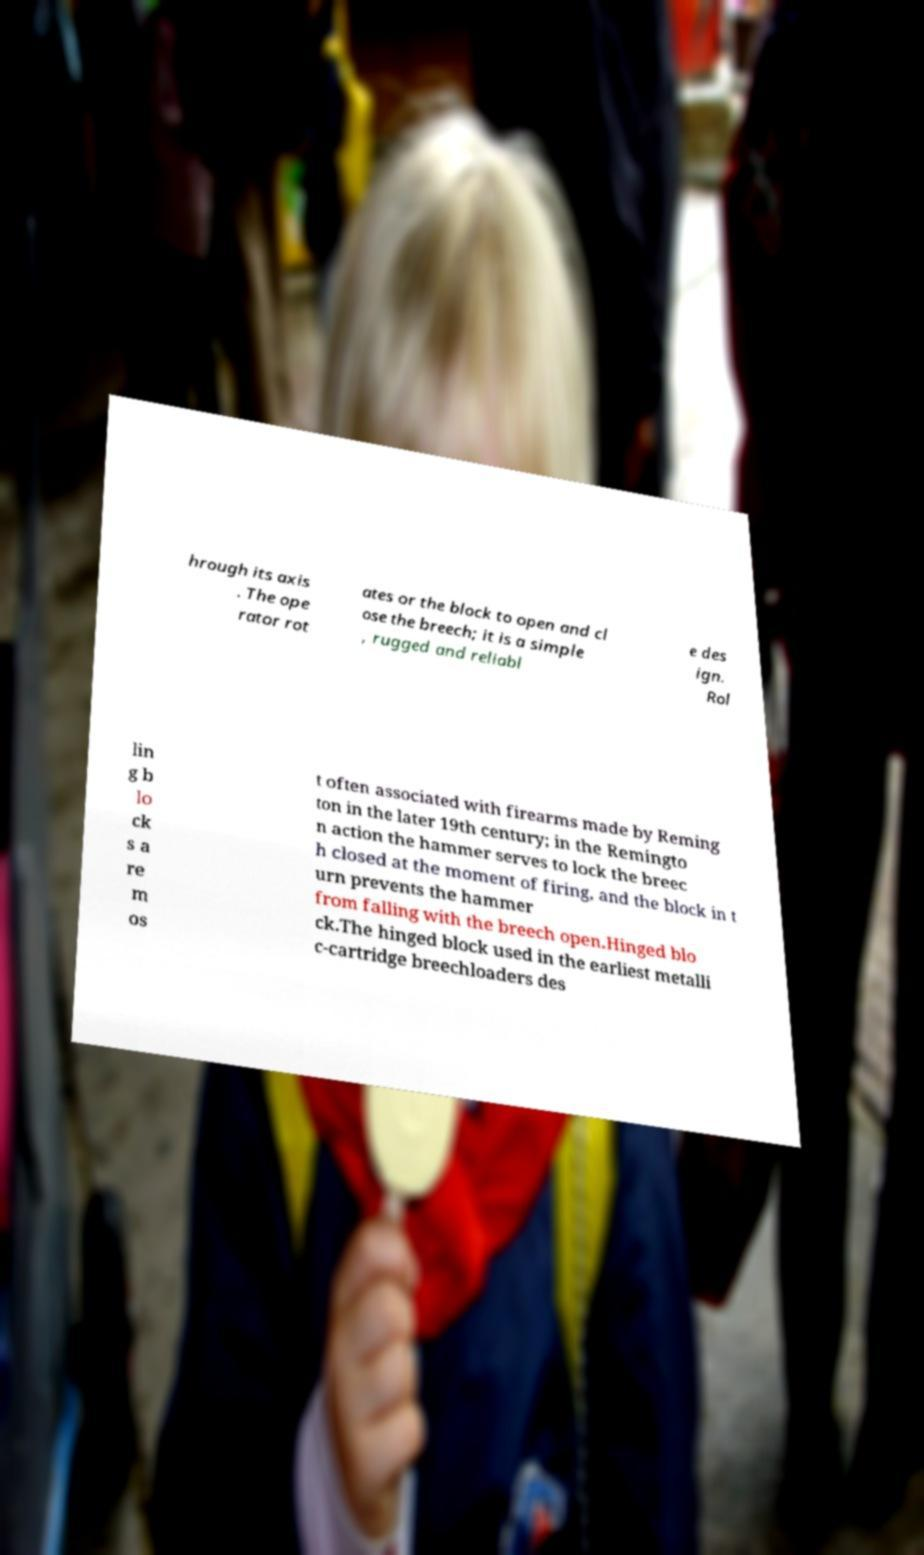Can you read and provide the text displayed in the image?This photo seems to have some interesting text. Can you extract and type it out for me? hrough its axis . The ope rator rot ates or the block to open and cl ose the breech; it is a simple , rugged and reliabl e des ign. Rol lin g b lo ck s a re m os t often associated with firearms made by Reming ton in the later 19th century; in the Remingto n action the hammer serves to lock the breec h closed at the moment of firing, and the block in t urn prevents the hammer from falling with the breech open.Hinged blo ck.The hinged block used in the earliest metalli c-cartridge breechloaders des 